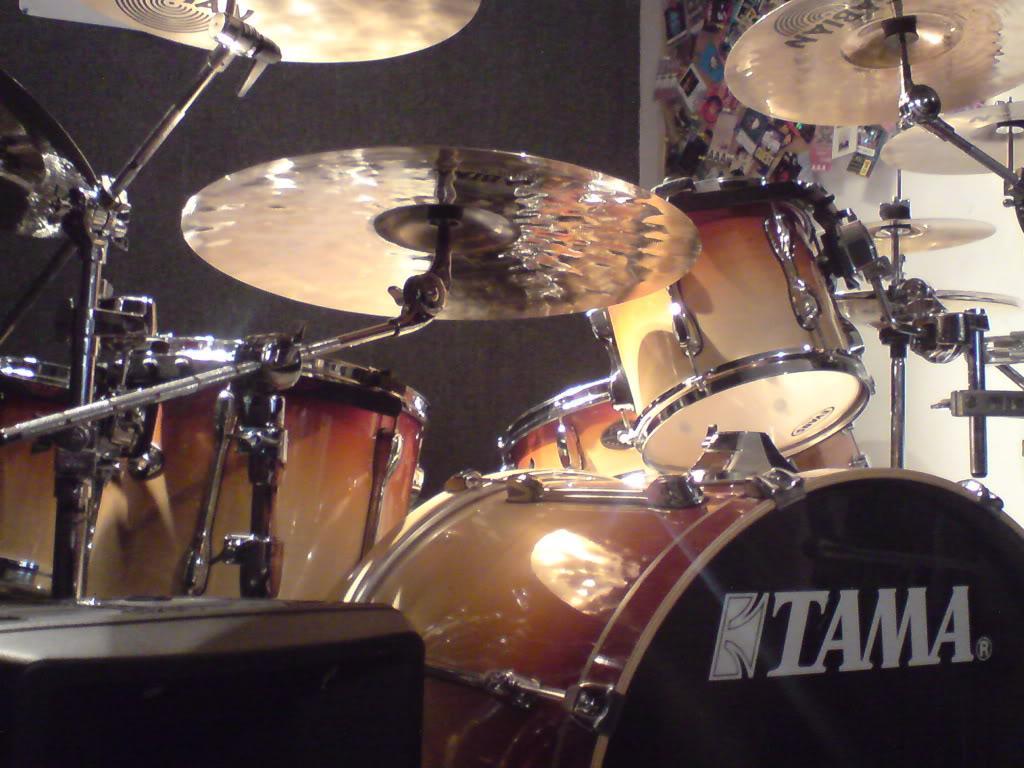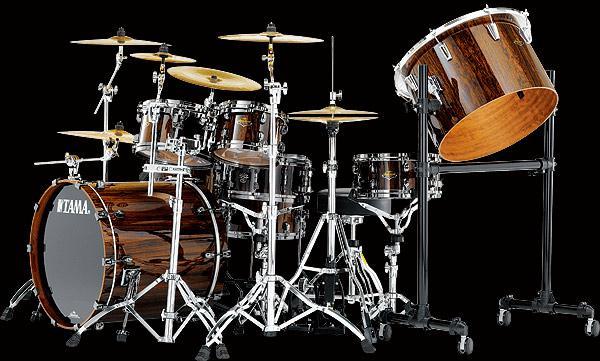The first image is the image on the left, the second image is the image on the right. For the images shown, is this caption "The right image contains a drum kit that is predominately red." true? Answer yes or no. No. The first image is the image on the left, the second image is the image on the right. Examine the images to the left and right. Is the description "Two drum kits in different sizes are shown, both with red drum facings and at least one forward-facing black drum." accurate? Answer yes or no. No. 